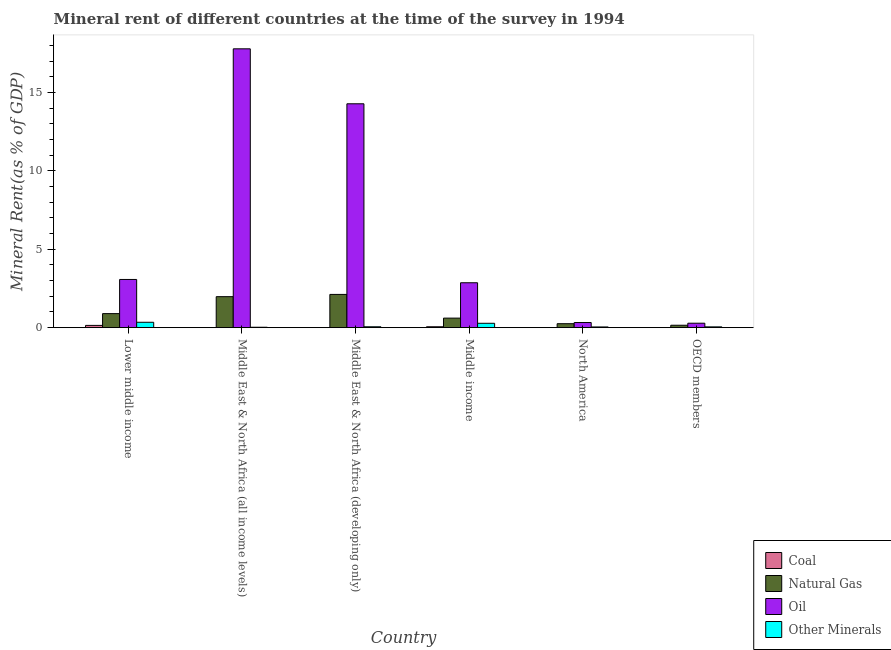How many different coloured bars are there?
Your response must be concise. 4. How many groups of bars are there?
Offer a terse response. 6. How many bars are there on the 5th tick from the left?
Ensure brevity in your answer.  4. What is the label of the 5th group of bars from the left?
Offer a very short reply. North America. What is the oil rent in Middle East & North Africa (all income levels)?
Your response must be concise. 17.79. Across all countries, what is the maximum natural gas rent?
Provide a short and direct response. 2.12. Across all countries, what is the minimum  rent of other minerals?
Provide a short and direct response. 0.03. In which country was the oil rent maximum?
Provide a succinct answer. Middle East & North Africa (all income levels). What is the total coal rent in the graph?
Make the answer very short. 0.21. What is the difference between the  rent of other minerals in Middle East & North Africa (developing only) and that in North America?
Offer a terse response. 0.01. What is the difference between the  rent of other minerals in Middle income and the oil rent in Middle East & North Africa (developing only)?
Offer a terse response. -14.01. What is the average natural gas rent per country?
Offer a very short reply. 1. What is the difference between the oil rent and  rent of other minerals in North America?
Offer a terse response. 0.28. In how many countries, is the oil rent greater than 9 %?
Offer a terse response. 2. What is the ratio of the coal rent in Middle income to that in North America?
Provide a short and direct response. 10.65. Is the  rent of other minerals in Middle East & North Africa (developing only) less than that in Middle income?
Keep it short and to the point. Yes. Is the difference between the natural gas rent in Middle East & North Africa (developing only) and North America greater than the difference between the  rent of other minerals in Middle East & North Africa (developing only) and North America?
Provide a succinct answer. Yes. What is the difference between the highest and the second highest oil rent?
Keep it short and to the point. 3.51. What is the difference between the highest and the lowest oil rent?
Offer a terse response. 17.51. In how many countries, is the oil rent greater than the average oil rent taken over all countries?
Your answer should be very brief. 2. Is the sum of the coal rent in Middle East & North Africa (developing only) and North America greater than the maximum oil rent across all countries?
Give a very brief answer. No. What does the 4th bar from the left in Middle East & North Africa (developing only) represents?
Make the answer very short. Other Minerals. What does the 2nd bar from the right in OECD members represents?
Ensure brevity in your answer.  Oil. Is it the case that in every country, the sum of the coal rent and natural gas rent is greater than the oil rent?
Keep it short and to the point. No. Are all the bars in the graph horizontal?
Provide a succinct answer. No. How many countries are there in the graph?
Your answer should be very brief. 6. Are the values on the major ticks of Y-axis written in scientific E-notation?
Make the answer very short. No. Does the graph contain any zero values?
Provide a short and direct response. No. How are the legend labels stacked?
Your answer should be very brief. Vertical. What is the title of the graph?
Make the answer very short. Mineral rent of different countries at the time of the survey in 1994. What is the label or title of the Y-axis?
Offer a very short reply. Mineral Rent(as % of GDP). What is the Mineral Rent(as % of GDP) in Coal in Lower middle income?
Provide a short and direct response. 0.14. What is the Mineral Rent(as % of GDP) in Natural Gas in Lower middle income?
Provide a succinct answer. 0.9. What is the Mineral Rent(as % of GDP) of Oil in Lower middle income?
Your answer should be compact. 3.08. What is the Mineral Rent(as % of GDP) of Other Minerals in Lower middle income?
Your answer should be very brief. 0.34. What is the Mineral Rent(as % of GDP) in Coal in Middle East & North Africa (all income levels)?
Make the answer very short. 0. What is the Mineral Rent(as % of GDP) of Natural Gas in Middle East & North Africa (all income levels)?
Ensure brevity in your answer.  1.98. What is the Mineral Rent(as % of GDP) in Oil in Middle East & North Africa (all income levels)?
Provide a succinct answer. 17.79. What is the Mineral Rent(as % of GDP) of Other Minerals in Middle East & North Africa (all income levels)?
Offer a very short reply. 0.03. What is the Mineral Rent(as % of GDP) of Coal in Middle East & North Africa (developing only)?
Provide a succinct answer. 0. What is the Mineral Rent(as % of GDP) of Natural Gas in Middle East & North Africa (developing only)?
Your answer should be compact. 2.12. What is the Mineral Rent(as % of GDP) in Oil in Middle East & North Africa (developing only)?
Provide a short and direct response. 14.28. What is the Mineral Rent(as % of GDP) of Other Minerals in Middle East & North Africa (developing only)?
Give a very brief answer. 0.06. What is the Mineral Rent(as % of GDP) of Coal in Middle income?
Offer a terse response. 0.06. What is the Mineral Rent(as % of GDP) of Natural Gas in Middle income?
Keep it short and to the point. 0.61. What is the Mineral Rent(as % of GDP) in Oil in Middle income?
Ensure brevity in your answer.  2.87. What is the Mineral Rent(as % of GDP) of Other Minerals in Middle income?
Offer a very short reply. 0.28. What is the Mineral Rent(as % of GDP) of Coal in North America?
Your answer should be very brief. 0.01. What is the Mineral Rent(as % of GDP) of Natural Gas in North America?
Your answer should be very brief. 0.25. What is the Mineral Rent(as % of GDP) of Oil in North America?
Provide a short and direct response. 0.33. What is the Mineral Rent(as % of GDP) in Other Minerals in North America?
Your answer should be compact. 0.05. What is the Mineral Rent(as % of GDP) of Coal in OECD members?
Keep it short and to the point. 0. What is the Mineral Rent(as % of GDP) in Natural Gas in OECD members?
Keep it short and to the point. 0.15. What is the Mineral Rent(as % of GDP) of Oil in OECD members?
Ensure brevity in your answer.  0.28. What is the Mineral Rent(as % of GDP) of Other Minerals in OECD members?
Make the answer very short. 0.05. Across all countries, what is the maximum Mineral Rent(as % of GDP) in Coal?
Your answer should be very brief. 0.14. Across all countries, what is the maximum Mineral Rent(as % of GDP) of Natural Gas?
Keep it short and to the point. 2.12. Across all countries, what is the maximum Mineral Rent(as % of GDP) of Oil?
Offer a terse response. 17.79. Across all countries, what is the maximum Mineral Rent(as % of GDP) in Other Minerals?
Offer a terse response. 0.34. Across all countries, what is the minimum Mineral Rent(as % of GDP) of Coal?
Ensure brevity in your answer.  0. Across all countries, what is the minimum Mineral Rent(as % of GDP) of Natural Gas?
Keep it short and to the point. 0.15. Across all countries, what is the minimum Mineral Rent(as % of GDP) of Oil?
Your answer should be very brief. 0.28. Across all countries, what is the minimum Mineral Rent(as % of GDP) in Other Minerals?
Your response must be concise. 0.03. What is the total Mineral Rent(as % of GDP) in Coal in the graph?
Give a very brief answer. 0.21. What is the total Mineral Rent(as % of GDP) of Natural Gas in the graph?
Give a very brief answer. 6.01. What is the total Mineral Rent(as % of GDP) in Oil in the graph?
Your response must be concise. 38.63. What is the total Mineral Rent(as % of GDP) of Other Minerals in the graph?
Provide a succinct answer. 0.8. What is the difference between the Mineral Rent(as % of GDP) in Coal in Lower middle income and that in Middle East & North Africa (all income levels)?
Keep it short and to the point. 0.14. What is the difference between the Mineral Rent(as % of GDP) in Natural Gas in Lower middle income and that in Middle East & North Africa (all income levels)?
Give a very brief answer. -1.08. What is the difference between the Mineral Rent(as % of GDP) in Oil in Lower middle income and that in Middle East & North Africa (all income levels)?
Provide a succinct answer. -14.72. What is the difference between the Mineral Rent(as % of GDP) of Other Minerals in Lower middle income and that in Middle East & North Africa (all income levels)?
Keep it short and to the point. 0.32. What is the difference between the Mineral Rent(as % of GDP) in Coal in Lower middle income and that in Middle East & North Africa (developing only)?
Keep it short and to the point. 0.14. What is the difference between the Mineral Rent(as % of GDP) of Natural Gas in Lower middle income and that in Middle East & North Africa (developing only)?
Provide a short and direct response. -1.23. What is the difference between the Mineral Rent(as % of GDP) in Oil in Lower middle income and that in Middle East & North Africa (developing only)?
Provide a short and direct response. -11.21. What is the difference between the Mineral Rent(as % of GDP) in Other Minerals in Lower middle income and that in Middle East & North Africa (developing only)?
Keep it short and to the point. 0.29. What is the difference between the Mineral Rent(as % of GDP) of Coal in Lower middle income and that in Middle income?
Provide a short and direct response. 0.09. What is the difference between the Mineral Rent(as % of GDP) in Natural Gas in Lower middle income and that in Middle income?
Your answer should be very brief. 0.29. What is the difference between the Mineral Rent(as % of GDP) of Oil in Lower middle income and that in Middle income?
Ensure brevity in your answer.  0.21. What is the difference between the Mineral Rent(as % of GDP) of Other Minerals in Lower middle income and that in Middle income?
Provide a succinct answer. 0.06. What is the difference between the Mineral Rent(as % of GDP) in Coal in Lower middle income and that in North America?
Provide a succinct answer. 0.14. What is the difference between the Mineral Rent(as % of GDP) in Natural Gas in Lower middle income and that in North America?
Your answer should be very brief. 0.64. What is the difference between the Mineral Rent(as % of GDP) of Oil in Lower middle income and that in North America?
Offer a very short reply. 2.75. What is the difference between the Mineral Rent(as % of GDP) of Other Minerals in Lower middle income and that in North America?
Your response must be concise. 0.3. What is the difference between the Mineral Rent(as % of GDP) of Coal in Lower middle income and that in OECD members?
Give a very brief answer. 0.14. What is the difference between the Mineral Rent(as % of GDP) of Natural Gas in Lower middle income and that in OECD members?
Provide a succinct answer. 0.74. What is the difference between the Mineral Rent(as % of GDP) of Oil in Lower middle income and that in OECD members?
Provide a short and direct response. 2.79. What is the difference between the Mineral Rent(as % of GDP) in Other Minerals in Lower middle income and that in OECD members?
Give a very brief answer. 0.29. What is the difference between the Mineral Rent(as % of GDP) in Coal in Middle East & North Africa (all income levels) and that in Middle East & North Africa (developing only)?
Your answer should be compact. -0. What is the difference between the Mineral Rent(as % of GDP) in Natural Gas in Middle East & North Africa (all income levels) and that in Middle East & North Africa (developing only)?
Offer a very short reply. -0.14. What is the difference between the Mineral Rent(as % of GDP) in Oil in Middle East & North Africa (all income levels) and that in Middle East & North Africa (developing only)?
Ensure brevity in your answer.  3.51. What is the difference between the Mineral Rent(as % of GDP) in Other Minerals in Middle East & North Africa (all income levels) and that in Middle East & North Africa (developing only)?
Your response must be concise. -0.03. What is the difference between the Mineral Rent(as % of GDP) of Coal in Middle East & North Africa (all income levels) and that in Middle income?
Provide a succinct answer. -0.06. What is the difference between the Mineral Rent(as % of GDP) of Natural Gas in Middle East & North Africa (all income levels) and that in Middle income?
Offer a very short reply. 1.37. What is the difference between the Mineral Rent(as % of GDP) of Oil in Middle East & North Africa (all income levels) and that in Middle income?
Make the answer very short. 14.93. What is the difference between the Mineral Rent(as % of GDP) of Other Minerals in Middle East & North Africa (all income levels) and that in Middle income?
Provide a succinct answer. -0.25. What is the difference between the Mineral Rent(as % of GDP) in Coal in Middle East & North Africa (all income levels) and that in North America?
Give a very brief answer. -0. What is the difference between the Mineral Rent(as % of GDP) of Natural Gas in Middle East & North Africa (all income levels) and that in North America?
Offer a very short reply. 1.72. What is the difference between the Mineral Rent(as % of GDP) in Oil in Middle East & North Africa (all income levels) and that in North America?
Keep it short and to the point. 17.46. What is the difference between the Mineral Rent(as % of GDP) in Other Minerals in Middle East & North Africa (all income levels) and that in North America?
Give a very brief answer. -0.02. What is the difference between the Mineral Rent(as % of GDP) in Coal in Middle East & North Africa (all income levels) and that in OECD members?
Provide a short and direct response. -0. What is the difference between the Mineral Rent(as % of GDP) in Natural Gas in Middle East & North Africa (all income levels) and that in OECD members?
Give a very brief answer. 1.82. What is the difference between the Mineral Rent(as % of GDP) in Oil in Middle East & North Africa (all income levels) and that in OECD members?
Your answer should be compact. 17.51. What is the difference between the Mineral Rent(as % of GDP) in Other Minerals in Middle East & North Africa (all income levels) and that in OECD members?
Keep it short and to the point. -0.02. What is the difference between the Mineral Rent(as % of GDP) of Coal in Middle East & North Africa (developing only) and that in Middle income?
Make the answer very short. -0.06. What is the difference between the Mineral Rent(as % of GDP) of Natural Gas in Middle East & North Africa (developing only) and that in Middle income?
Offer a very short reply. 1.51. What is the difference between the Mineral Rent(as % of GDP) of Oil in Middle East & North Africa (developing only) and that in Middle income?
Provide a succinct answer. 11.42. What is the difference between the Mineral Rent(as % of GDP) of Other Minerals in Middle East & North Africa (developing only) and that in Middle income?
Provide a short and direct response. -0.22. What is the difference between the Mineral Rent(as % of GDP) of Coal in Middle East & North Africa (developing only) and that in North America?
Your answer should be compact. -0. What is the difference between the Mineral Rent(as % of GDP) in Natural Gas in Middle East & North Africa (developing only) and that in North America?
Ensure brevity in your answer.  1.87. What is the difference between the Mineral Rent(as % of GDP) of Oil in Middle East & North Africa (developing only) and that in North America?
Give a very brief answer. 13.96. What is the difference between the Mineral Rent(as % of GDP) of Other Minerals in Middle East & North Africa (developing only) and that in North America?
Make the answer very short. 0.01. What is the difference between the Mineral Rent(as % of GDP) of Coal in Middle East & North Africa (developing only) and that in OECD members?
Offer a very short reply. 0. What is the difference between the Mineral Rent(as % of GDP) in Natural Gas in Middle East & North Africa (developing only) and that in OECD members?
Make the answer very short. 1.97. What is the difference between the Mineral Rent(as % of GDP) of Oil in Middle East & North Africa (developing only) and that in OECD members?
Make the answer very short. 14. What is the difference between the Mineral Rent(as % of GDP) of Other Minerals in Middle East & North Africa (developing only) and that in OECD members?
Ensure brevity in your answer.  0.01. What is the difference between the Mineral Rent(as % of GDP) of Coal in Middle income and that in North America?
Provide a short and direct response. 0.05. What is the difference between the Mineral Rent(as % of GDP) in Natural Gas in Middle income and that in North America?
Give a very brief answer. 0.36. What is the difference between the Mineral Rent(as % of GDP) of Oil in Middle income and that in North America?
Provide a succinct answer. 2.54. What is the difference between the Mineral Rent(as % of GDP) of Other Minerals in Middle income and that in North America?
Provide a short and direct response. 0.23. What is the difference between the Mineral Rent(as % of GDP) of Coal in Middle income and that in OECD members?
Your answer should be very brief. 0.06. What is the difference between the Mineral Rent(as % of GDP) of Natural Gas in Middle income and that in OECD members?
Provide a succinct answer. 0.45. What is the difference between the Mineral Rent(as % of GDP) of Oil in Middle income and that in OECD members?
Keep it short and to the point. 2.58. What is the difference between the Mineral Rent(as % of GDP) in Other Minerals in Middle income and that in OECD members?
Provide a short and direct response. 0.23. What is the difference between the Mineral Rent(as % of GDP) of Coal in North America and that in OECD members?
Your answer should be very brief. 0. What is the difference between the Mineral Rent(as % of GDP) of Natural Gas in North America and that in OECD members?
Provide a short and direct response. 0.1. What is the difference between the Mineral Rent(as % of GDP) of Oil in North America and that in OECD members?
Keep it short and to the point. 0.04. What is the difference between the Mineral Rent(as % of GDP) in Other Minerals in North America and that in OECD members?
Provide a succinct answer. -0. What is the difference between the Mineral Rent(as % of GDP) in Coal in Lower middle income and the Mineral Rent(as % of GDP) in Natural Gas in Middle East & North Africa (all income levels)?
Keep it short and to the point. -1.83. What is the difference between the Mineral Rent(as % of GDP) in Coal in Lower middle income and the Mineral Rent(as % of GDP) in Oil in Middle East & North Africa (all income levels)?
Provide a short and direct response. -17.65. What is the difference between the Mineral Rent(as % of GDP) in Coal in Lower middle income and the Mineral Rent(as % of GDP) in Other Minerals in Middle East & North Africa (all income levels)?
Provide a succinct answer. 0.12. What is the difference between the Mineral Rent(as % of GDP) in Natural Gas in Lower middle income and the Mineral Rent(as % of GDP) in Oil in Middle East & North Africa (all income levels)?
Offer a very short reply. -16.9. What is the difference between the Mineral Rent(as % of GDP) in Natural Gas in Lower middle income and the Mineral Rent(as % of GDP) in Other Minerals in Middle East & North Africa (all income levels)?
Your answer should be very brief. 0.87. What is the difference between the Mineral Rent(as % of GDP) of Oil in Lower middle income and the Mineral Rent(as % of GDP) of Other Minerals in Middle East & North Africa (all income levels)?
Offer a terse response. 3.05. What is the difference between the Mineral Rent(as % of GDP) in Coal in Lower middle income and the Mineral Rent(as % of GDP) in Natural Gas in Middle East & North Africa (developing only)?
Offer a very short reply. -1.98. What is the difference between the Mineral Rent(as % of GDP) of Coal in Lower middle income and the Mineral Rent(as % of GDP) of Oil in Middle East & North Africa (developing only)?
Your answer should be very brief. -14.14. What is the difference between the Mineral Rent(as % of GDP) of Coal in Lower middle income and the Mineral Rent(as % of GDP) of Other Minerals in Middle East & North Africa (developing only)?
Provide a succinct answer. 0.09. What is the difference between the Mineral Rent(as % of GDP) of Natural Gas in Lower middle income and the Mineral Rent(as % of GDP) of Oil in Middle East & North Africa (developing only)?
Your response must be concise. -13.39. What is the difference between the Mineral Rent(as % of GDP) of Natural Gas in Lower middle income and the Mineral Rent(as % of GDP) of Other Minerals in Middle East & North Africa (developing only)?
Make the answer very short. 0.84. What is the difference between the Mineral Rent(as % of GDP) in Oil in Lower middle income and the Mineral Rent(as % of GDP) in Other Minerals in Middle East & North Africa (developing only)?
Keep it short and to the point. 3.02. What is the difference between the Mineral Rent(as % of GDP) of Coal in Lower middle income and the Mineral Rent(as % of GDP) of Natural Gas in Middle income?
Provide a succinct answer. -0.46. What is the difference between the Mineral Rent(as % of GDP) in Coal in Lower middle income and the Mineral Rent(as % of GDP) in Oil in Middle income?
Ensure brevity in your answer.  -2.72. What is the difference between the Mineral Rent(as % of GDP) of Coal in Lower middle income and the Mineral Rent(as % of GDP) of Other Minerals in Middle income?
Provide a short and direct response. -0.13. What is the difference between the Mineral Rent(as % of GDP) in Natural Gas in Lower middle income and the Mineral Rent(as % of GDP) in Oil in Middle income?
Make the answer very short. -1.97. What is the difference between the Mineral Rent(as % of GDP) of Natural Gas in Lower middle income and the Mineral Rent(as % of GDP) of Other Minerals in Middle income?
Your answer should be very brief. 0.62. What is the difference between the Mineral Rent(as % of GDP) of Oil in Lower middle income and the Mineral Rent(as % of GDP) of Other Minerals in Middle income?
Keep it short and to the point. 2.8. What is the difference between the Mineral Rent(as % of GDP) of Coal in Lower middle income and the Mineral Rent(as % of GDP) of Natural Gas in North America?
Provide a short and direct response. -0.11. What is the difference between the Mineral Rent(as % of GDP) in Coal in Lower middle income and the Mineral Rent(as % of GDP) in Oil in North America?
Give a very brief answer. -0.18. What is the difference between the Mineral Rent(as % of GDP) of Coal in Lower middle income and the Mineral Rent(as % of GDP) of Other Minerals in North America?
Offer a terse response. 0.1. What is the difference between the Mineral Rent(as % of GDP) of Natural Gas in Lower middle income and the Mineral Rent(as % of GDP) of Oil in North America?
Give a very brief answer. 0.57. What is the difference between the Mineral Rent(as % of GDP) in Natural Gas in Lower middle income and the Mineral Rent(as % of GDP) in Other Minerals in North America?
Offer a very short reply. 0.85. What is the difference between the Mineral Rent(as % of GDP) in Oil in Lower middle income and the Mineral Rent(as % of GDP) in Other Minerals in North America?
Keep it short and to the point. 3.03. What is the difference between the Mineral Rent(as % of GDP) in Coal in Lower middle income and the Mineral Rent(as % of GDP) in Natural Gas in OECD members?
Your answer should be very brief. -0.01. What is the difference between the Mineral Rent(as % of GDP) in Coal in Lower middle income and the Mineral Rent(as % of GDP) in Oil in OECD members?
Provide a short and direct response. -0.14. What is the difference between the Mineral Rent(as % of GDP) of Coal in Lower middle income and the Mineral Rent(as % of GDP) of Other Minerals in OECD members?
Offer a terse response. 0.09. What is the difference between the Mineral Rent(as % of GDP) in Natural Gas in Lower middle income and the Mineral Rent(as % of GDP) in Oil in OECD members?
Provide a succinct answer. 0.61. What is the difference between the Mineral Rent(as % of GDP) in Natural Gas in Lower middle income and the Mineral Rent(as % of GDP) in Other Minerals in OECD members?
Provide a short and direct response. 0.85. What is the difference between the Mineral Rent(as % of GDP) in Oil in Lower middle income and the Mineral Rent(as % of GDP) in Other Minerals in OECD members?
Offer a very short reply. 3.02. What is the difference between the Mineral Rent(as % of GDP) of Coal in Middle East & North Africa (all income levels) and the Mineral Rent(as % of GDP) of Natural Gas in Middle East & North Africa (developing only)?
Keep it short and to the point. -2.12. What is the difference between the Mineral Rent(as % of GDP) of Coal in Middle East & North Africa (all income levels) and the Mineral Rent(as % of GDP) of Oil in Middle East & North Africa (developing only)?
Ensure brevity in your answer.  -14.28. What is the difference between the Mineral Rent(as % of GDP) in Coal in Middle East & North Africa (all income levels) and the Mineral Rent(as % of GDP) in Other Minerals in Middle East & North Africa (developing only)?
Provide a succinct answer. -0.06. What is the difference between the Mineral Rent(as % of GDP) of Natural Gas in Middle East & North Africa (all income levels) and the Mineral Rent(as % of GDP) of Oil in Middle East & North Africa (developing only)?
Your response must be concise. -12.31. What is the difference between the Mineral Rent(as % of GDP) of Natural Gas in Middle East & North Africa (all income levels) and the Mineral Rent(as % of GDP) of Other Minerals in Middle East & North Africa (developing only)?
Offer a terse response. 1.92. What is the difference between the Mineral Rent(as % of GDP) in Oil in Middle East & North Africa (all income levels) and the Mineral Rent(as % of GDP) in Other Minerals in Middle East & North Africa (developing only)?
Your answer should be compact. 17.74. What is the difference between the Mineral Rent(as % of GDP) in Coal in Middle East & North Africa (all income levels) and the Mineral Rent(as % of GDP) in Natural Gas in Middle income?
Your answer should be compact. -0.61. What is the difference between the Mineral Rent(as % of GDP) in Coal in Middle East & North Africa (all income levels) and the Mineral Rent(as % of GDP) in Oil in Middle income?
Your answer should be very brief. -2.86. What is the difference between the Mineral Rent(as % of GDP) of Coal in Middle East & North Africa (all income levels) and the Mineral Rent(as % of GDP) of Other Minerals in Middle income?
Offer a terse response. -0.28. What is the difference between the Mineral Rent(as % of GDP) of Natural Gas in Middle East & North Africa (all income levels) and the Mineral Rent(as % of GDP) of Oil in Middle income?
Your answer should be compact. -0.89. What is the difference between the Mineral Rent(as % of GDP) in Natural Gas in Middle East & North Africa (all income levels) and the Mineral Rent(as % of GDP) in Other Minerals in Middle income?
Your response must be concise. 1.7. What is the difference between the Mineral Rent(as % of GDP) in Oil in Middle East & North Africa (all income levels) and the Mineral Rent(as % of GDP) in Other Minerals in Middle income?
Provide a succinct answer. 17.51. What is the difference between the Mineral Rent(as % of GDP) in Coal in Middle East & North Africa (all income levels) and the Mineral Rent(as % of GDP) in Natural Gas in North America?
Provide a short and direct response. -0.25. What is the difference between the Mineral Rent(as % of GDP) in Coal in Middle East & North Africa (all income levels) and the Mineral Rent(as % of GDP) in Oil in North America?
Your response must be concise. -0.33. What is the difference between the Mineral Rent(as % of GDP) of Coal in Middle East & North Africa (all income levels) and the Mineral Rent(as % of GDP) of Other Minerals in North America?
Offer a terse response. -0.05. What is the difference between the Mineral Rent(as % of GDP) of Natural Gas in Middle East & North Africa (all income levels) and the Mineral Rent(as % of GDP) of Oil in North America?
Provide a succinct answer. 1.65. What is the difference between the Mineral Rent(as % of GDP) in Natural Gas in Middle East & North Africa (all income levels) and the Mineral Rent(as % of GDP) in Other Minerals in North America?
Make the answer very short. 1.93. What is the difference between the Mineral Rent(as % of GDP) of Oil in Middle East & North Africa (all income levels) and the Mineral Rent(as % of GDP) of Other Minerals in North America?
Keep it short and to the point. 17.75. What is the difference between the Mineral Rent(as % of GDP) of Coal in Middle East & North Africa (all income levels) and the Mineral Rent(as % of GDP) of Natural Gas in OECD members?
Offer a terse response. -0.15. What is the difference between the Mineral Rent(as % of GDP) in Coal in Middle East & North Africa (all income levels) and the Mineral Rent(as % of GDP) in Oil in OECD members?
Your response must be concise. -0.28. What is the difference between the Mineral Rent(as % of GDP) of Coal in Middle East & North Africa (all income levels) and the Mineral Rent(as % of GDP) of Other Minerals in OECD members?
Provide a short and direct response. -0.05. What is the difference between the Mineral Rent(as % of GDP) of Natural Gas in Middle East & North Africa (all income levels) and the Mineral Rent(as % of GDP) of Oil in OECD members?
Your answer should be very brief. 1.69. What is the difference between the Mineral Rent(as % of GDP) in Natural Gas in Middle East & North Africa (all income levels) and the Mineral Rent(as % of GDP) in Other Minerals in OECD members?
Provide a succinct answer. 1.93. What is the difference between the Mineral Rent(as % of GDP) in Oil in Middle East & North Africa (all income levels) and the Mineral Rent(as % of GDP) in Other Minerals in OECD members?
Make the answer very short. 17.74. What is the difference between the Mineral Rent(as % of GDP) of Coal in Middle East & North Africa (developing only) and the Mineral Rent(as % of GDP) of Natural Gas in Middle income?
Offer a very short reply. -0.61. What is the difference between the Mineral Rent(as % of GDP) of Coal in Middle East & North Africa (developing only) and the Mineral Rent(as % of GDP) of Oil in Middle income?
Ensure brevity in your answer.  -2.86. What is the difference between the Mineral Rent(as % of GDP) of Coal in Middle East & North Africa (developing only) and the Mineral Rent(as % of GDP) of Other Minerals in Middle income?
Give a very brief answer. -0.28. What is the difference between the Mineral Rent(as % of GDP) in Natural Gas in Middle East & North Africa (developing only) and the Mineral Rent(as % of GDP) in Oil in Middle income?
Provide a short and direct response. -0.74. What is the difference between the Mineral Rent(as % of GDP) of Natural Gas in Middle East & North Africa (developing only) and the Mineral Rent(as % of GDP) of Other Minerals in Middle income?
Your answer should be very brief. 1.84. What is the difference between the Mineral Rent(as % of GDP) of Oil in Middle East & North Africa (developing only) and the Mineral Rent(as % of GDP) of Other Minerals in Middle income?
Your answer should be compact. 14.01. What is the difference between the Mineral Rent(as % of GDP) in Coal in Middle East & North Africa (developing only) and the Mineral Rent(as % of GDP) in Natural Gas in North America?
Provide a succinct answer. -0.25. What is the difference between the Mineral Rent(as % of GDP) in Coal in Middle East & North Africa (developing only) and the Mineral Rent(as % of GDP) in Oil in North America?
Provide a succinct answer. -0.33. What is the difference between the Mineral Rent(as % of GDP) of Coal in Middle East & North Africa (developing only) and the Mineral Rent(as % of GDP) of Other Minerals in North America?
Keep it short and to the point. -0.04. What is the difference between the Mineral Rent(as % of GDP) of Natural Gas in Middle East & North Africa (developing only) and the Mineral Rent(as % of GDP) of Oil in North America?
Keep it short and to the point. 1.79. What is the difference between the Mineral Rent(as % of GDP) in Natural Gas in Middle East & North Africa (developing only) and the Mineral Rent(as % of GDP) in Other Minerals in North America?
Your answer should be very brief. 2.08. What is the difference between the Mineral Rent(as % of GDP) in Oil in Middle East & North Africa (developing only) and the Mineral Rent(as % of GDP) in Other Minerals in North America?
Offer a very short reply. 14.24. What is the difference between the Mineral Rent(as % of GDP) in Coal in Middle East & North Africa (developing only) and the Mineral Rent(as % of GDP) in Natural Gas in OECD members?
Ensure brevity in your answer.  -0.15. What is the difference between the Mineral Rent(as % of GDP) of Coal in Middle East & North Africa (developing only) and the Mineral Rent(as % of GDP) of Oil in OECD members?
Offer a terse response. -0.28. What is the difference between the Mineral Rent(as % of GDP) in Coal in Middle East & North Africa (developing only) and the Mineral Rent(as % of GDP) in Other Minerals in OECD members?
Provide a succinct answer. -0.05. What is the difference between the Mineral Rent(as % of GDP) of Natural Gas in Middle East & North Africa (developing only) and the Mineral Rent(as % of GDP) of Oil in OECD members?
Keep it short and to the point. 1.84. What is the difference between the Mineral Rent(as % of GDP) in Natural Gas in Middle East & North Africa (developing only) and the Mineral Rent(as % of GDP) in Other Minerals in OECD members?
Keep it short and to the point. 2.07. What is the difference between the Mineral Rent(as % of GDP) of Oil in Middle East & North Africa (developing only) and the Mineral Rent(as % of GDP) of Other Minerals in OECD members?
Offer a terse response. 14.23. What is the difference between the Mineral Rent(as % of GDP) in Coal in Middle income and the Mineral Rent(as % of GDP) in Natural Gas in North America?
Offer a very short reply. -0.2. What is the difference between the Mineral Rent(as % of GDP) in Coal in Middle income and the Mineral Rent(as % of GDP) in Oil in North America?
Your answer should be compact. -0.27. What is the difference between the Mineral Rent(as % of GDP) in Coal in Middle income and the Mineral Rent(as % of GDP) in Other Minerals in North America?
Offer a very short reply. 0.01. What is the difference between the Mineral Rent(as % of GDP) of Natural Gas in Middle income and the Mineral Rent(as % of GDP) of Oil in North America?
Give a very brief answer. 0.28. What is the difference between the Mineral Rent(as % of GDP) in Natural Gas in Middle income and the Mineral Rent(as % of GDP) in Other Minerals in North America?
Make the answer very short. 0.56. What is the difference between the Mineral Rent(as % of GDP) in Oil in Middle income and the Mineral Rent(as % of GDP) in Other Minerals in North America?
Your response must be concise. 2.82. What is the difference between the Mineral Rent(as % of GDP) of Coal in Middle income and the Mineral Rent(as % of GDP) of Natural Gas in OECD members?
Keep it short and to the point. -0.1. What is the difference between the Mineral Rent(as % of GDP) in Coal in Middle income and the Mineral Rent(as % of GDP) in Oil in OECD members?
Make the answer very short. -0.23. What is the difference between the Mineral Rent(as % of GDP) of Coal in Middle income and the Mineral Rent(as % of GDP) of Other Minerals in OECD members?
Give a very brief answer. 0.01. What is the difference between the Mineral Rent(as % of GDP) in Natural Gas in Middle income and the Mineral Rent(as % of GDP) in Oil in OECD members?
Your response must be concise. 0.32. What is the difference between the Mineral Rent(as % of GDP) of Natural Gas in Middle income and the Mineral Rent(as % of GDP) of Other Minerals in OECD members?
Make the answer very short. 0.56. What is the difference between the Mineral Rent(as % of GDP) of Oil in Middle income and the Mineral Rent(as % of GDP) of Other Minerals in OECD members?
Provide a short and direct response. 2.81. What is the difference between the Mineral Rent(as % of GDP) in Coal in North America and the Mineral Rent(as % of GDP) in Natural Gas in OECD members?
Your answer should be very brief. -0.15. What is the difference between the Mineral Rent(as % of GDP) of Coal in North America and the Mineral Rent(as % of GDP) of Oil in OECD members?
Your response must be concise. -0.28. What is the difference between the Mineral Rent(as % of GDP) of Coal in North America and the Mineral Rent(as % of GDP) of Other Minerals in OECD members?
Provide a short and direct response. -0.05. What is the difference between the Mineral Rent(as % of GDP) of Natural Gas in North America and the Mineral Rent(as % of GDP) of Oil in OECD members?
Offer a terse response. -0.03. What is the difference between the Mineral Rent(as % of GDP) in Natural Gas in North America and the Mineral Rent(as % of GDP) in Other Minerals in OECD members?
Your answer should be very brief. 0.2. What is the difference between the Mineral Rent(as % of GDP) of Oil in North America and the Mineral Rent(as % of GDP) of Other Minerals in OECD members?
Your response must be concise. 0.28. What is the average Mineral Rent(as % of GDP) in Coal per country?
Provide a succinct answer. 0.04. What is the average Mineral Rent(as % of GDP) in Oil per country?
Your answer should be very brief. 6.44. What is the average Mineral Rent(as % of GDP) in Other Minerals per country?
Your response must be concise. 0.13. What is the difference between the Mineral Rent(as % of GDP) in Coal and Mineral Rent(as % of GDP) in Natural Gas in Lower middle income?
Ensure brevity in your answer.  -0.75. What is the difference between the Mineral Rent(as % of GDP) in Coal and Mineral Rent(as % of GDP) in Oil in Lower middle income?
Provide a succinct answer. -2.93. What is the difference between the Mineral Rent(as % of GDP) in Coal and Mineral Rent(as % of GDP) in Other Minerals in Lower middle income?
Your response must be concise. -0.2. What is the difference between the Mineral Rent(as % of GDP) in Natural Gas and Mineral Rent(as % of GDP) in Oil in Lower middle income?
Provide a short and direct response. -2.18. What is the difference between the Mineral Rent(as % of GDP) of Natural Gas and Mineral Rent(as % of GDP) of Other Minerals in Lower middle income?
Your response must be concise. 0.55. What is the difference between the Mineral Rent(as % of GDP) in Oil and Mineral Rent(as % of GDP) in Other Minerals in Lower middle income?
Your response must be concise. 2.73. What is the difference between the Mineral Rent(as % of GDP) in Coal and Mineral Rent(as % of GDP) in Natural Gas in Middle East & North Africa (all income levels)?
Provide a short and direct response. -1.98. What is the difference between the Mineral Rent(as % of GDP) of Coal and Mineral Rent(as % of GDP) of Oil in Middle East & North Africa (all income levels)?
Ensure brevity in your answer.  -17.79. What is the difference between the Mineral Rent(as % of GDP) in Coal and Mineral Rent(as % of GDP) in Other Minerals in Middle East & North Africa (all income levels)?
Your answer should be compact. -0.03. What is the difference between the Mineral Rent(as % of GDP) in Natural Gas and Mineral Rent(as % of GDP) in Oil in Middle East & North Africa (all income levels)?
Offer a very short reply. -15.81. What is the difference between the Mineral Rent(as % of GDP) of Natural Gas and Mineral Rent(as % of GDP) of Other Minerals in Middle East & North Africa (all income levels)?
Offer a very short reply. 1.95. What is the difference between the Mineral Rent(as % of GDP) in Oil and Mineral Rent(as % of GDP) in Other Minerals in Middle East & North Africa (all income levels)?
Ensure brevity in your answer.  17.77. What is the difference between the Mineral Rent(as % of GDP) of Coal and Mineral Rent(as % of GDP) of Natural Gas in Middle East & North Africa (developing only)?
Your answer should be compact. -2.12. What is the difference between the Mineral Rent(as % of GDP) of Coal and Mineral Rent(as % of GDP) of Oil in Middle East & North Africa (developing only)?
Offer a very short reply. -14.28. What is the difference between the Mineral Rent(as % of GDP) in Coal and Mineral Rent(as % of GDP) in Other Minerals in Middle East & North Africa (developing only)?
Provide a short and direct response. -0.05. What is the difference between the Mineral Rent(as % of GDP) of Natural Gas and Mineral Rent(as % of GDP) of Oil in Middle East & North Africa (developing only)?
Your response must be concise. -12.16. What is the difference between the Mineral Rent(as % of GDP) in Natural Gas and Mineral Rent(as % of GDP) in Other Minerals in Middle East & North Africa (developing only)?
Your answer should be compact. 2.06. What is the difference between the Mineral Rent(as % of GDP) in Oil and Mineral Rent(as % of GDP) in Other Minerals in Middle East & North Africa (developing only)?
Offer a terse response. 14.23. What is the difference between the Mineral Rent(as % of GDP) of Coal and Mineral Rent(as % of GDP) of Natural Gas in Middle income?
Your response must be concise. -0.55. What is the difference between the Mineral Rent(as % of GDP) in Coal and Mineral Rent(as % of GDP) in Oil in Middle income?
Make the answer very short. -2.81. What is the difference between the Mineral Rent(as % of GDP) of Coal and Mineral Rent(as % of GDP) of Other Minerals in Middle income?
Provide a short and direct response. -0.22. What is the difference between the Mineral Rent(as % of GDP) of Natural Gas and Mineral Rent(as % of GDP) of Oil in Middle income?
Offer a very short reply. -2.26. What is the difference between the Mineral Rent(as % of GDP) of Natural Gas and Mineral Rent(as % of GDP) of Other Minerals in Middle income?
Make the answer very short. 0.33. What is the difference between the Mineral Rent(as % of GDP) in Oil and Mineral Rent(as % of GDP) in Other Minerals in Middle income?
Offer a very short reply. 2.59. What is the difference between the Mineral Rent(as % of GDP) of Coal and Mineral Rent(as % of GDP) of Natural Gas in North America?
Provide a short and direct response. -0.25. What is the difference between the Mineral Rent(as % of GDP) of Coal and Mineral Rent(as % of GDP) of Oil in North America?
Make the answer very short. -0.32. What is the difference between the Mineral Rent(as % of GDP) in Coal and Mineral Rent(as % of GDP) in Other Minerals in North America?
Provide a succinct answer. -0.04. What is the difference between the Mineral Rent(as % of GDP) in Natural Gas and Mineral Rent(as % of GDP) in Oil in North America?
Your answer should be compact. -0.08. What is the difference between the Mineral Rent(as % of GDP) in Natural Gas and Mineral Rent(as % of GDP) in Other Minerals in North America?
Your response must be concise. 0.21. What is the difference between the Mineral Rent(as % of GDP) of Oil and Mineral Rent(as % of GDP) of Other Minerals in North America?
Your response must be concise. 0.28. What is the difference between the Mineral Rent(as % of GDP) in Coal and Mineral Rent(as % of GDP) in Natural Gas in OECD members?
Provide a succinct answer. -0.15. What is the difference between the Mineral Rent(as % of GDP) of Coal and Mineral Rent(as % of GDP) of Oil in OECD members?
Provide a succinct answer. -0.28. What is the difference between the Mineral Rent(as % of GDP) in Coal and Mineral Rent(as % of GDP) in Other Minerals in OECD members?
Provide a succinct answer. -0.05. What is the difference between the Mineral Rent(as % of GDP) of Natural Gas and Mineral Rent(as % of GDP) of Oil in OECD members?
Ensure brevity in your answer.  -0.13. What is the difference between the Mineral Rent(as % of GDP) in Natural Gas and Mineral Rent(as % of GDP) in Other Minerals in OECD members?
Your answer should be very brief. 0.1. What is the difference between the Mineral Rent(as % of GDP) of Oil and Mineral Rent(as % of GDP) of Other Minerals in OECD members?
Make the answer very short. 0.23. What is the ratio of the Mineral Rent(as % of GDP) in Coal in Lower middle income to that in Middle East & North Africa (all income levels)?
Give a very brief answer. 149.4. What is the ratio of the Mineral Rent(as % of GDP) in Natural Gas in Lower middle income to that in Middle East & North Africa (all income levels)?
Keep it short and to the point. 0.45. What is the ratio of the Mineral Rent(as % of GDP) of Oil in Lower middle income to that in Middle East & North Africa (all income levels)?
Keep it short and to the point. 0.17. What is the ratio of the Mineral Rent(as % of GDP) in Other Minerals in Lower middle income to that in Middle East & North Africa (all income levels)?
Ensure brevity in your answer.  12.76. What is the ratio of the Mineral Rent(as % of GDP) in Coal in Lower middle income to that in Middle East & North Africa (developing only)?
Ensure brevity in your answer.  69.23. What is the ratio of the Mineral Rent(as % of GDP) of Natural Gas in Lower middle income to that in Middle East & North Africa (developing only)?
Keep it short and to the point. 0.42. What is the ratio of the Mineral Rent(as % of GDP) in Oil in Lower middle income to that in Middle East & North Africa (developing only)?
Make the answer very short. 0.22. What is the ratio of the Mineral Rent(as % of GDP) of Other Minerals in Lower middle income to that in Middle East & North Africa (developing only)?
Keep it short and to the point. 6.07. What is the ratio of the Mineral Rent(as % of GDP) of Coal in Lower middle income to that in Middle income?
Provide a succinct answer. 2.52. What is the ratio of the Mineral Rent(as % of GDP) in Natural Gas in Lower middle income to that in Middle income?
Ensure brevity in your answer.  1.47. What is the ratio of the Mineral Rent(as % of GDP) in Oil in Lower middle income to that in Middle income?
Give a very brief answer. 1.07. What is the ratio of the Mineral Rent(as % of GDP) in Other Minerals in Lower middle income to that in Middle income?
Provide a succinct answer. 1.23. What is the ratio of the Mineral Rent(as % of GDP) of Coal in Lower middle income to that in North America?
Your answer should be compact. 26.83. What is the ratio of the Mineral Rent(as % of GDP) of Natural Gas in Lower middle income to that in North America?
Give a very brief answer. 3.54. What is the ratio of the Mineral Rent(as % of GDP) in Oil in Lower middle income to that in North America?
Ensure brevity in your answer.  9.36. What is the ratio of the Mineral Rent(as % of GDP) in Other Minerals in Lower middle income to that in North America?
Give a very brief answer. 7.46. What is the ratio of the Mineral Rent(as % of GDP) of Coal in Lower middle income to that in OECD members?
Provide a short and direct response. 73.2. What is the ratio of the Mineral Rent(as % of GDP) in Natural Gas in Lower middle income to that in OECD members?
Give a very brief answer. 5.81. What is the ratio of the Mineral Rent(as % of GDP) of Oil in Lower middle income to that in OECD members?
Provide a short and direct response. 10.81. What is the ratio of the Mineral Rent(as % of GDP) of Other Minerals in Lower middle income to that in OECD members?
Ensure brevity in your answer.  6.81. What is the ratio of the Mineral Rent(as % of GDP) in Coal in Middle East & North Africa (all income levels) to that in Middle East & North Africa (developing only)?
Your answer should be compact. 0.46. What is the ratio of the Mineral Rent(as % of GDP) of Natural Gas in Middle East & North Africa (all income levels) to that in Middle East & North Africa (developing only)?
Your response must be concise. 0.93. What is the ratio of the Mineral Rent(as % of GDP) in Oil in Middle East & North Africa (all income levels) to that in Middle East & North Africa (developing only)?
Keep it short and to the point. 1.25. What is the ratio of the Mineral Rent(as % of GDP) of Other Minerals in Middle East & North Africa (all income levels) to that in Middle East & North Africa (developing only)?
Make the answer very short. 0.48. What is the ratio of the Mineral Rent(as % of GDP) in Coal in Middle East & North Africa (all income levels) to that in Middle income?
Make the answer very short. 0.02. What is the ratio of the Mineral Rent(as % of GDP) in Natural Gas in Middle East & North Africa (all income levels) to that in Middle income?
Your response must be concise. 3.25. What is the ratio of the Mineral Rent(as % of GDP) in Oil in Middle East & North Africa (all income levels) to that in Middle income?
Give a very brief answer. 6.21. What is the ratio of the Mineral Rent(as % of GDP) in Other Minerals in Middle East & North Africa (all income levels) to that in Middle income?
Provide a short and direct response. 0.1. What is the ratio of the Mineral Rent(as % of GDP) in Coal in Middle East & North Africa (all income levels) to that in North America?
Your response must be concise. 0.18. What is the ratio of the Mineral Rent(as % of GDP) of Natural Gas in Middle East & North Africa (all income levels) to that in North America?
Your response must be concise. 7.82. What is the ratio of the Mineral Rent(as % of GDP) in Oil in Middle East & North Africa (all income levels) to that in North America?
Give a very brief answer. 54.17. What is the ratio of the Mineral Rent(as % of GDP) of Other Minerals in Middle East & North Africa (all income levels) to that in North America?
Your answer should be very brief. 0.58. What is the ratio of the Mineral Rent(as % of GDP) of Coal in Middle East & North Africa (all income levels) to that in OECD members?
Offer a very short reply. 0.49. What is the ratio of the Mineral Rent(as % of GDP) in Natural Gas in Middle East & North Africa (all income levels) to that in OECD members?
Your answer should be compact. 12.82. What is the ratio of the Mineral Rent(as % of GDP) in Oil in Middle East & North Africa (all income levels) to that in OECD members?
Make the answer very short. 62.52. What is the ratio of the Mineral Rent(as % of GDP) of Other Minerals in Middle East & North Africa (all income levels) to that in OECD members?
Give a very brief answer. 0.53. What is the ratio of the Mineral Rent(as % of GDP) of Coal in Middle East & North Africa (developing only) to that in Middle income?
Your answer should be compact. 0.04. What is the ratio of the Mineral Rent(as % of GDP) in Natural Gas in Middle East & North Africa (developing only) to that in Middle income?
Offer a terse response. 3.48. What is the ratio of the Mineral Rent(as % of GDP) of Oil in Middle East & North Africa (developing only) to that in Middle income?
Ensure brevity in your answer.  4.99. What is the ratio of the Mineral Rent(as % of GDP) of Other Minerals in Middle East & North Africa (developing only) to that in Middle income?
Give a very brief answer. 0.2. What is the ratio of the Mineral Rent(as % of GDP) of Coal in Middle East & North Africa (developing only) to that in North America?
Your answer should be very brief. 0.39. What is the ratio of the Mineral Rent(as % of GDP) of Natural Gas in Middle East & North Africa (developing only) to that in North America?
Your response must be concise. 8.39. What is the ratio of the Mineral Rent(as % of GDP) of Oil in Middle East & North Africa (developing only) to that in North America?
Make the answer very short. 43.49. What is the ratio of the Mineral Rent(as % of GDP) of Other Minerals in Middle East & North Africa (developing only) to that in North America?
Make the answer very short. 1.23. What is the ratio of the Mineral Rent(as % of GDP) of Coal in Middle East & North Africa (developing only) to that in OECD members?
Make the answer very short. 1.06. What is the ratio of the Mineral Rent(as % of GDP) of Natural Gas in Middle East & North Africa (developing only) to that in OECD members?
Provide a succinct answer. 13.75. What is the ratio of the Mineral Rent(as % of GDP) in Oil in Middle East & North Africa (developing only) to that in OECD members?
Provide a short and direct response. 50.2. What is the ratio of the Mineral Rent(as % of GDP) in Other Minerals in Middle East & North Africa (developing only) to that in OECD members?
Offer a very short reply. 1.12. What is the ratio of the Mineral Rent(as % of GDP) of Coal in Middle income to that in North America?
Provide a short and direct response. 10.65. What is the ratio of the Mineral Rent(as % of GDP) in Natural Gas in Middle income to that in North America?
Ensure brevity in your answer.  2.41. What is the ratio of the Mineral Rent(as % of GDP) in Oil in Middle income to that in North America?
Provide a succinct answer. 8.72. What is the ratio of the Mineral Rent(as % of GDP) of Other Minerals in Middle income to that in North America?
Give a very brief answer. 6.07. What is the ratio of the Mineral Rent(as % of GDP) of Coal in Middle income to that in OECD members?
Provide a succinct answer. 29.05. What is the ratio of the Mineral Rent(as % of GDP) in Natural Gas in Middle income to that in OECD members?
Provide a short and direct response. 3.95. What is the ratio of the Mineral Rent(as % of GDP) in Oil in Middle income to that in OECD members?
Offer a very short reply. 10.07. What is the ratio of the Mineral Rent(as % of GDP) of Other Minerals in Middle income to that in OECD members?
Ensure brevity in your answer.  5.54. What is the ratio of the Mineral Rent(as % of GDP) of Coal in North America to that in OECD members?
Provide a short and direct response. 2.73. What is the ratio of the Mineral Rent(as % of GDP) of Natural Gas in North America to that in OECD members?
Offer a very short reply. 1.64. What is the ratio of the Mineral Rent(as % of GDP) in Oil in North America to that in OECD members?
Offer a terse response. 1.15. What is the ratio of the Mineral Rent(as % of GDP) in Other Minerals in North America to that in OECD members?
Provide a succinct answer. 0.91. What is the difference between the highest and the second highest Mineral Rent(as % of GDP) of Coal?
Your answer should be compact. 0.09. What is the difference between the highest and the second highest Mineral Rent(as % of GDP) in Natural Gas?
Offer a terse response. 0.14. What is the difference between the highest and the second highest Mineral Rent(as % of GDP) in Oil?
Make the answer very short. 3.51. What is the difference between the highest and the second highest Mineral Rent(as % of GDP) of Other Minerals?
Offer a terse response. 0.06. What is the difference between the highest and the lowest Mineral Rent(as % of GDP) of Coal?
Your response must be concise. 0.14. What is the difference between the highest and the lowest Mineral Rent(as % of GDP) in Natural Gas?
Keep it short and to the point. 1.97. What is the difference between the highest and the lowest Mineral Rent(as % of GDP) of Oil?
Provide a succinct answer. 17.51. What is the difference between the highest and the lowest Mineral Rent(as % of GDP) of Other Minerals?
Your response must be concise. 0.32. 